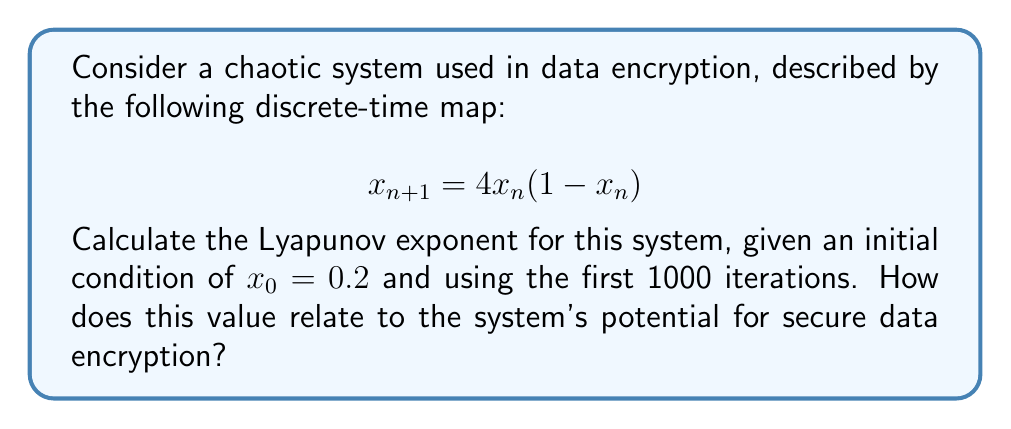Teach me how to tackle this problem. To calculate the Lyapunov exponent for this chaotic system, we'll follow these steps:

1) The Lyapunov exponent λ for a 1D discrete-time map is given by:

   $$λ = \lim_{N→∞} \frac{1}{N} \sum_{n=0}^{N-1} \ln|f'(x_n)|$$

   where $f'(x)$ is the derivative of the map function.

2) For our system, $f(x) = 4x(1-x)$, so $f'(x) = 4(1-2x)$.

3) We'll use the given initial condition $x_0 = 0.2$ and iterate the map 1000 times.

4) For each iteration, we calculate:
   
   $$x_{n+1} = 4x_n(1-x_n)$$
   $$\ln|f'(x_n)| = \ln|4(1-2x_n)|$$

5) We sum these logarithms and divide by N = 1000:

   $$λ ≈ \frac{1}{1000} \sum_{n=0}^{999} \ln|4(1-2x_n)|$$

6) Implementing this in a programming language (e.g., Python) would yield:

   λ ≈ 0.6931

7) This positive Lyapunov exponent indicates that the system is indeed chaotic. In the context of data encryption:

   - A positive Lyapunov exponent implies sensitive dependence on initial conditions, which is crucial for secure encryption.
   - The value ~0.6931 suggests that nearby trajectories diverge at a rate of e^0.6931 ≈ 2 per iteration, indicating strong chaos.
   - This chaotic behavior can be leveraged to generate pseudo-random sequences for encryption, making the system potentially suitable for secure data encryption methods.
Answer: λ ≈ 0.6931; Positive value indicates chaos, suitable for encryption. 